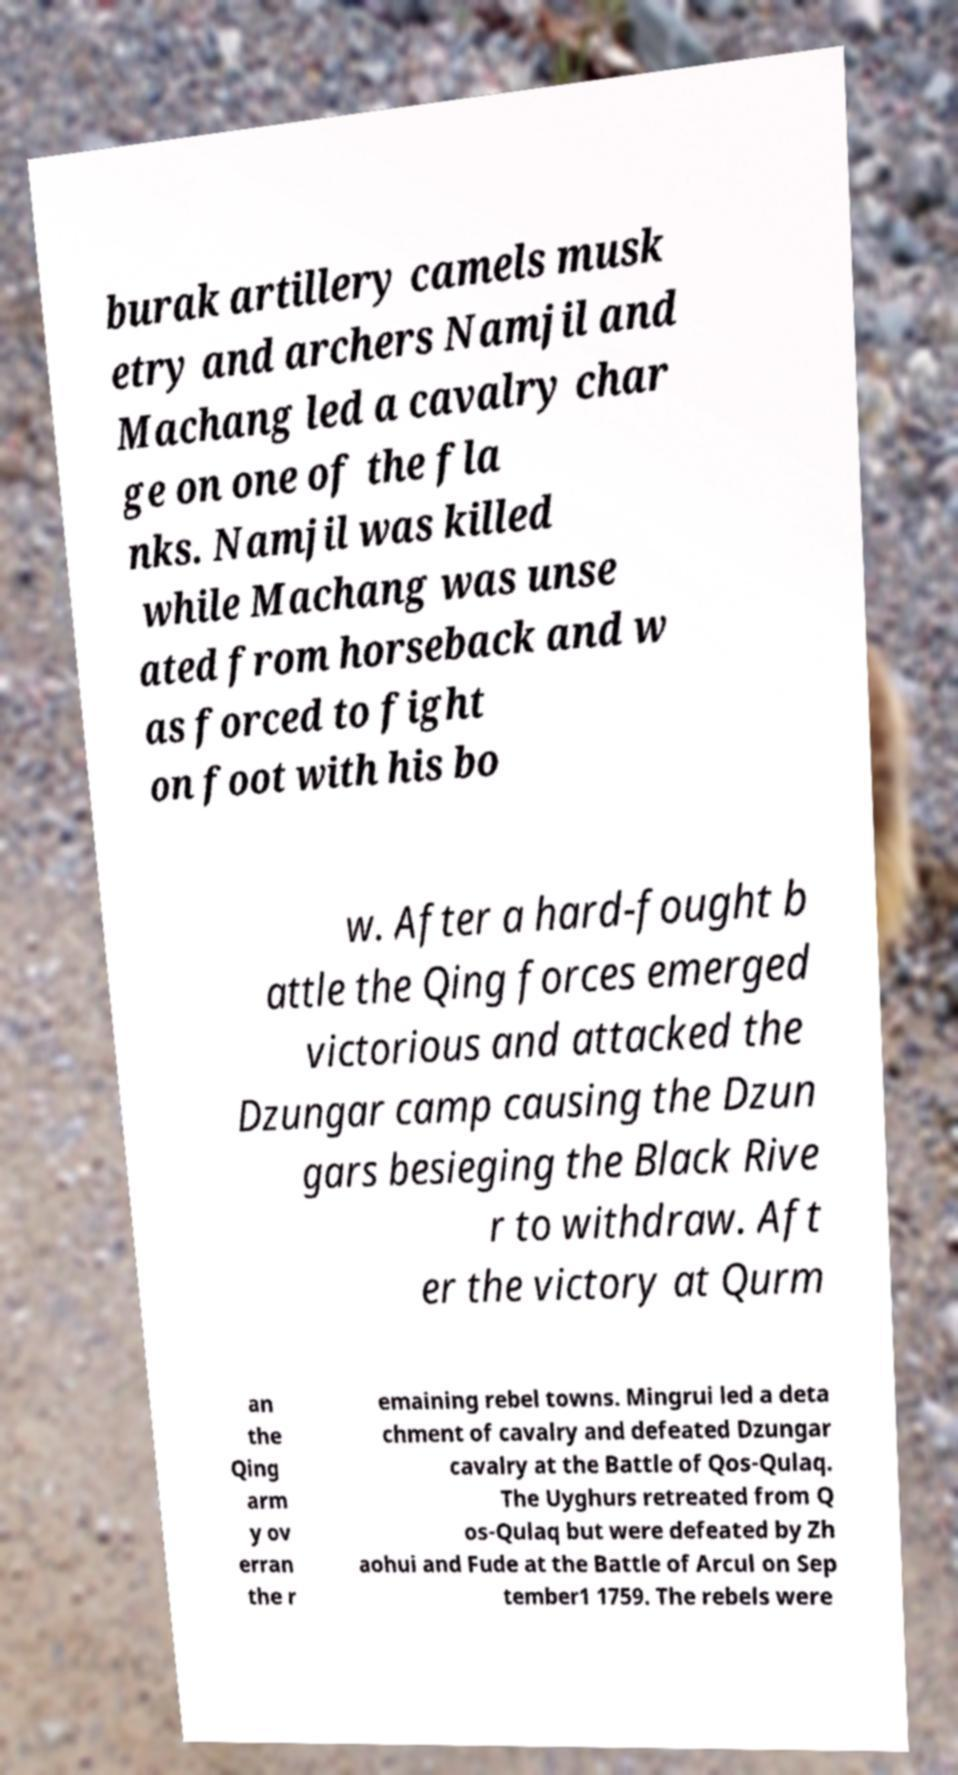Please read and relay the text visible in this image. What does it say? burak artillery camels musk etry and archers Namjil and Machang led a cavalry char ge on one of the fla nks. Namjil was killed while Machang was unse ated from horseback and w as forced to fight on foot with his bo w. After a hard-fought b attle the Qing forces emerged victorious and attacked the Dzungar camp causing the Dzun gars besieging the Black Rive r to withdraw. Aft er the victory at Qurm an the Qing arm y ov erran the r emaining rebel towns. Mingrui led a deta chment of cavalry and defeated Dzungar cavalry at the Battle of Qos-Qulaq. The Uyghurs retreated from Q os-Qulaq but were defeated by Zh aohui and Fude at the Battle of Arcul on Sep tember1 1759. The rebels were 